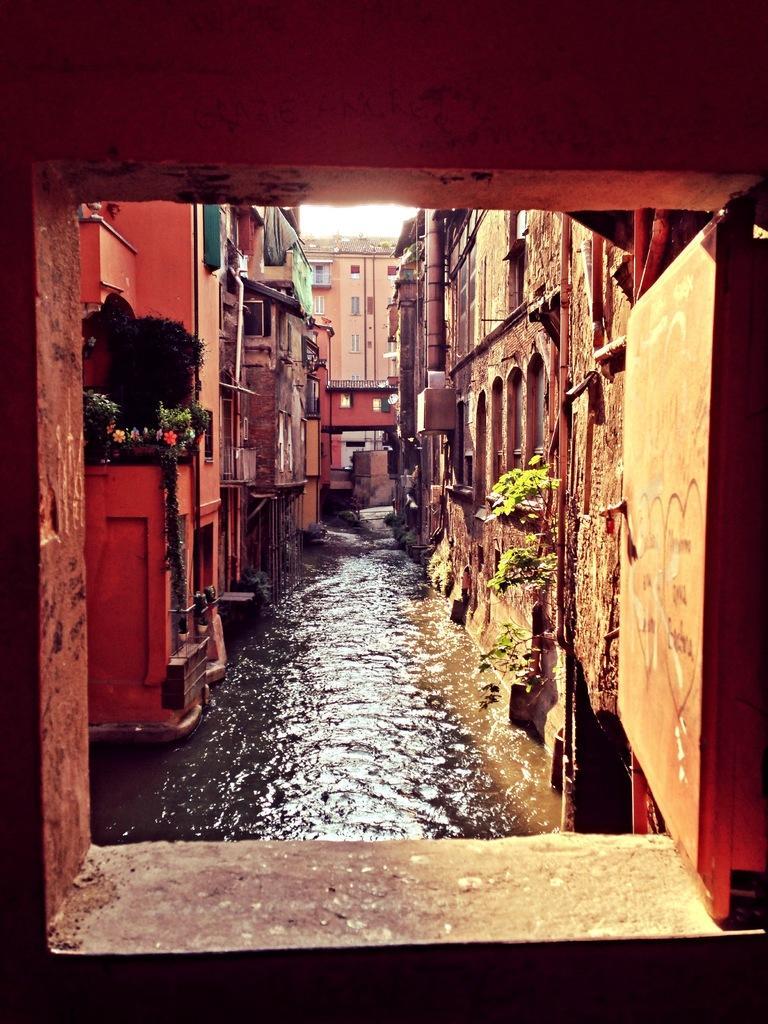Please provide a concise description of this image. There is a sewage water flowing behind the houses,around that sewage there are a lot of buildings. 